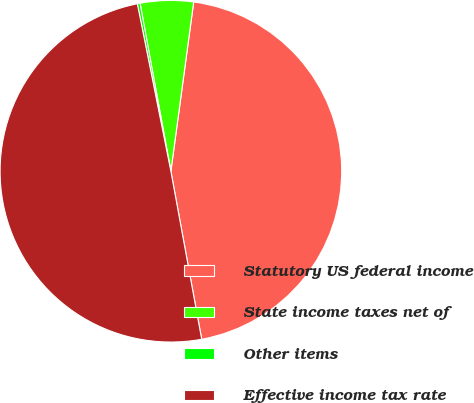<chart> <loc_0><loc_0><loc_500><loc_500><pie_chart><fcel>Statutory US federal income<fcel>State income taxes net of<fcel>Other items<fcel>Effective income tax rate<nl><fcel>44.98%<fcel>5.02%<fcel>0.26%<fcel>49.74%<nl></chart> 